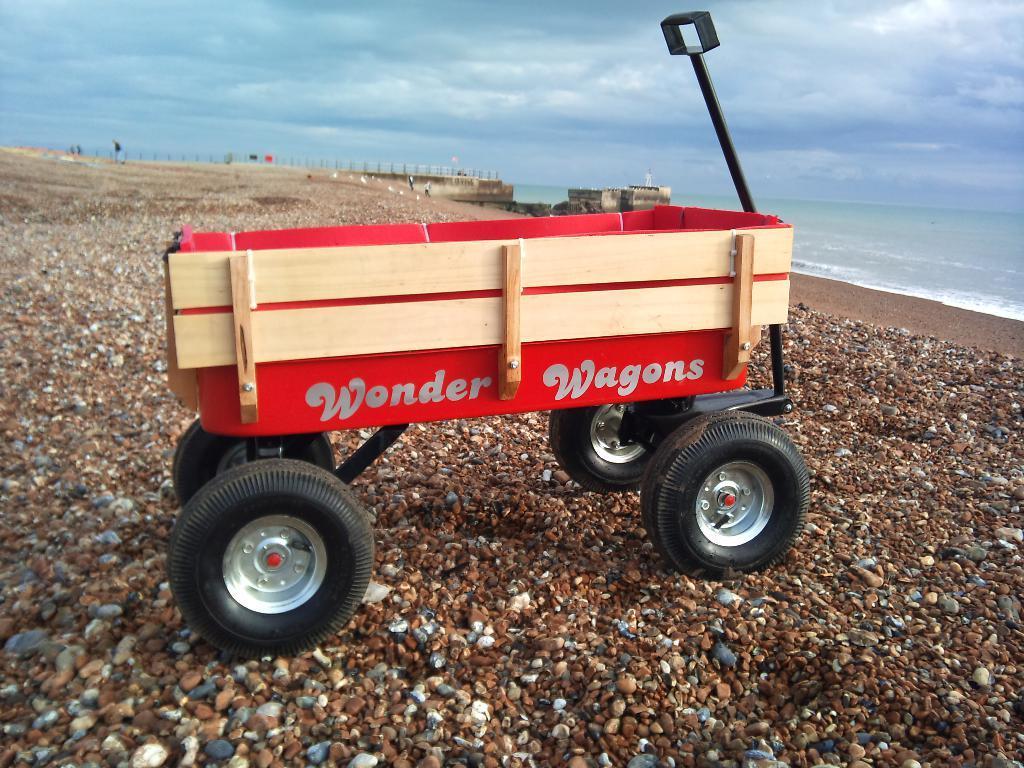How would you summarize this image in a sentence or two? In this picture, we can see a beach wagon on the path and behind the beach wagon there is a sea and a cloudy sky. 